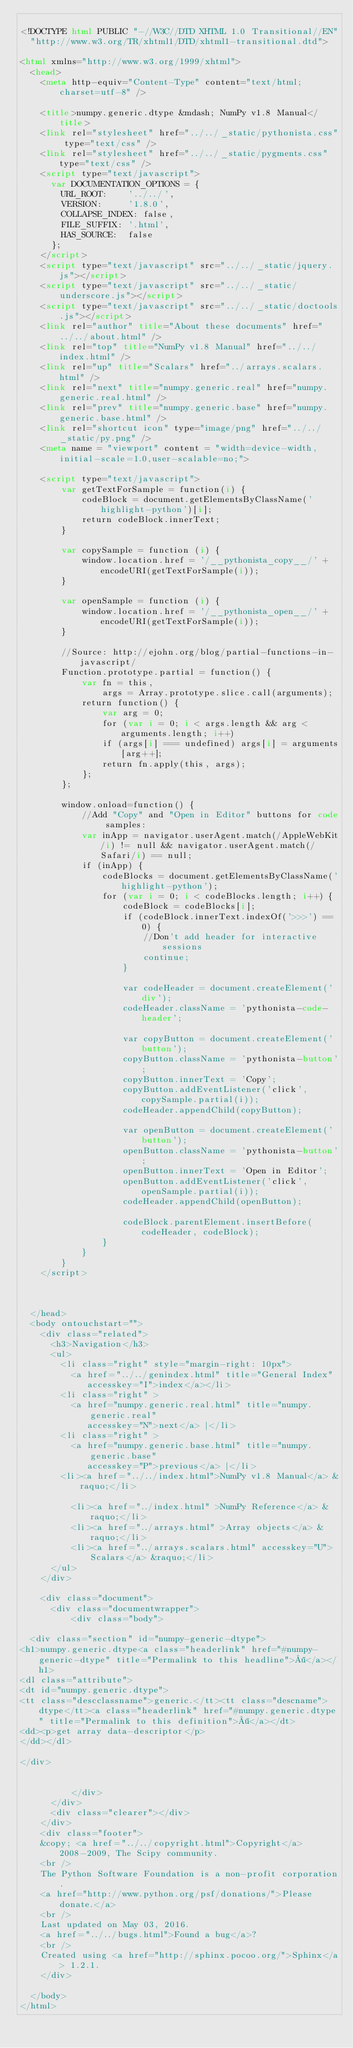<code> <loc_0><loc_0><loc_500><loc_500><_HTML_>
<!DOCTYPE html PUBLIC "-//W3C//DTD XHTML 1.0 Transitional//EN"
  "http://www.w3.org/TR/xhtml1/DTD/xhtml1-transitional.dtd">

<html xmlns="http://www.w3.org/1999/xhtml">
  <head>
    <meta http-equiv="Content-Type" content="text/html; charset=utf-8" />
    
    <title>numpy.generic.dtype &mdash; NumPy v1.8 Manual</title>
    <link rel="stylesheet" href="../../_static/pythonista.css" type="text/css" />
    <link rel="stylesheet" href="../../_static/pygments.css" type="text/css" />
    <script type="text/javascript">
      var DOCUMENTATION_OPTIONS = {
        URL_ROOT:    '../../',
        VERSION:     '1.8.0',
        COLLAPSE_INDEX: false,
        FILE_SUFFIX: '.html',
        HAS_SOURCE:  false
      };
    </script>
    <script type="text/javascript" src="../../_static/jquery.js"></script>
    <script type="text/javascript" src="../../_static/underscore.js"></script>
    <script type="text/javascript" src="../../_static/doctools.js"></script>
    <link rel="author" title="About these documents" href="../../about.html" />
    <link rel="top" title="NumPy v1.8 Manual" href="../../index.html" />
    <link rel="up" title="Scalars" href="../arrays.scalars.html" />
    <link rel="next" title="numpy.generic.real" href="numpy.generic.real.html" />
    <link rel="prev" title="numpy.generic.base" href="numpy.generic.base.html" />
    <link rel="shortcut icon" type="image/png" href="../../_static/py.png" />
    <meta name = "viewport" content = "width=device-width,initial-scale=1.0,user-scalable=no;">
    
    <script type="text/javascript">
        var getTextForSample = function(i) {
            codeBlock = document.getElementsByClassName('highlight-python')[i];
            return codeBlock.innerText;
        }
        
        var copySample = function (i) {
            window.location.href = '/__pythonista_copy__/' + encodeURI(getTextForSample(i));
        }
        
        var openSample = function (i) {
            window.location.href = '/__pythonista_open__/' + encodeURI(getTextForSample(i));
        }
        
        //Source: http://ejohn.org/blog/partial-functions-in-javascript/
        Function.prototype.partial = function() {
        	var fn = this,
        		args = Array.prototype.slice.call(arguments);
        	return function() {
        		var arg = 0;
        		for (var i = 0; i < args.length && arg < arguments.length; i++)
        		if (args[i] === undefined) args[i] = arguments[arg++];
        		return fn.apply(this, args);
        	};
        };
        
        window.onload=function() {
            //Add "Copy" and "Open in Editor" buttons for code samples:
            var inApp = navigator.userAgent.match(/AppleWebKit/i) != null && navigator.userAgent.match(/Safari/i) == null;
            if (inApp) {
                codeBlocks = document.getElementsByClassName('highlight-python');
                for (var i = 0; i < codeBlocks.length; i++) {
                    codeBlock = codeBlocks[i];
                    if (codeBlock.innerText.indexOf('>>>') == 0) {
                        //Don't add header for interactive sessions
                        continue;
                    }

                    var codeHeader = document.createElement('div');
                    codeHeader.className = 'pythonista-code-header';

                    var copyButton = document.createElement('button');
                    copyButton.className = 'pythonista-button';
                    copyButton.innerText = 'Copy';
                    copyButton.addEventListener('click', copySample.partial(i));
                    codeHeader.appendChild(copyButton);

                    var openButton = document.createElement('button');
                    openButton.className = 'pythonista-button';
                    openButton.innerText = 'Open in Editor';
                    openButton.addEventListener('click', openSample.partial(i));
                    codeHeader.appendChild(openButton);

                    codeBlock.parentElement.insertBefore(codeHeader, codeBlock);
                }
            }
        }
    </script>
    
 

  </head>
  <body ontouchstart="">
    <div class="related">
      <h3>Navigation</h3>
      <ul>
        <li class="right" style="margin-right: 10px">
          <a href="../../genindex.html" title="General Index"
             accesskey="I">index</a></li>
        <li class="right" >
          <a href="numpy.generic.real.html" title="numpy.generic.real"
             accesskey="N">next</a> |</li>
        <li class="right" >
          <a href="numpy.generic.base.html" title="numpy.generic.base"
             accesskey="P">previous</a> |</li>
        <li><a href="../../index.html">NumPy v1.8 Manual</a> &raquo;</li>

          <li><a href="../index.html" >NumPy Reference</a> &raquo;</li>
          <li><a href="../arrays.html" >Array objects</a> &raquo;</li>
          <li><a href="../arrays.scalars.html" accesskey="U">Scalars</a> &raquo;</li> 
      </ul>
    </div>  

    <div class="document">
      <div class="documentwrapper">
          <div class="body">
            
  <div class="section" id="numpy-generic-dtype">
<h1>numpy.generic.dtype<a class="headerlink" href="#numpy-generic-dtype" title="Permalink to this headline">¶</a></h1>
<dl class="attribute">
<dt id="numpy.generic.dtype">
<tt class="descclassname">generic.</tt><tt class="descname">dtype</tt><a class="headerlink" href="#numpy.generic.dtype" title="Permalink to this definition">¶</a></dt>
<dd><p>get array data-descriptor</p>
</dd></dl>

</div>


          </div>
      </div>
      <div class="clearer"></div>
    </div>
    <div class="footer">
    &copy; <a href="../../copyright.html">Copyright</a> 2008-2009, The Scipy community.
    <br />
    The Python Software Foundation is a non-profit corporation.  
    <a href="http://www.python.org/psf/donations/">Please donate.</a>
    <br />
    Last updated on May 03, 2016.
    <a href="../../bugs.html">Found a bug</a>?
    <br />
    Created using <a href="http://sphinx.pocoo.org/">Sphinx</a> 1.2.1.
    </div>

  </body>
</html></code> 